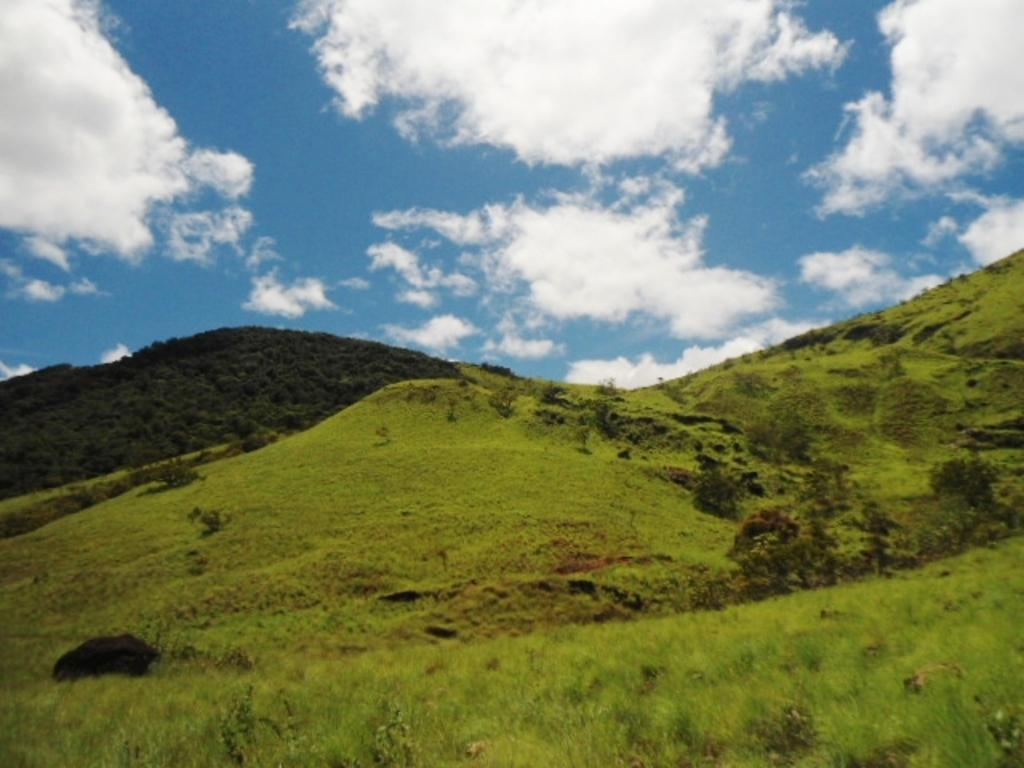What type of vegetation is present in the image? There is grass in the image. What other natural elements can be seen in the image? There are trees and hills visible in the image. What is visible in the background of the image? There are clouds visible in the background of the image. What type of drum can be seen in the image? There is no drum present in the image. What disease is affecting the trees in the image? There is no indication of any disease affecting the trees in the image. 